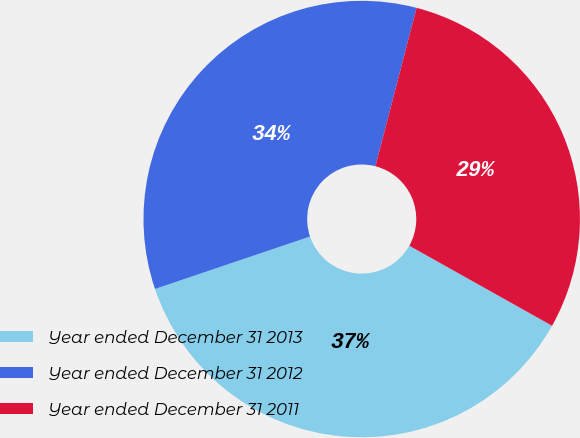Convert chart. <chart><loc_0><loc_0><loc_500><loc_500><pie_chart><fcel>Year ended December 31 2013<fcel>Year ended December 31 2012<fcel>Year ended December 31 2011<nl><fcel>36.68%<fcel>34.24%<fcel>29.09%<nl></chart> 